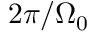<formula> <loc_0><loc_0><loc_500><loc_500>2 \pi / \Omega _ { 0 }</formula> 